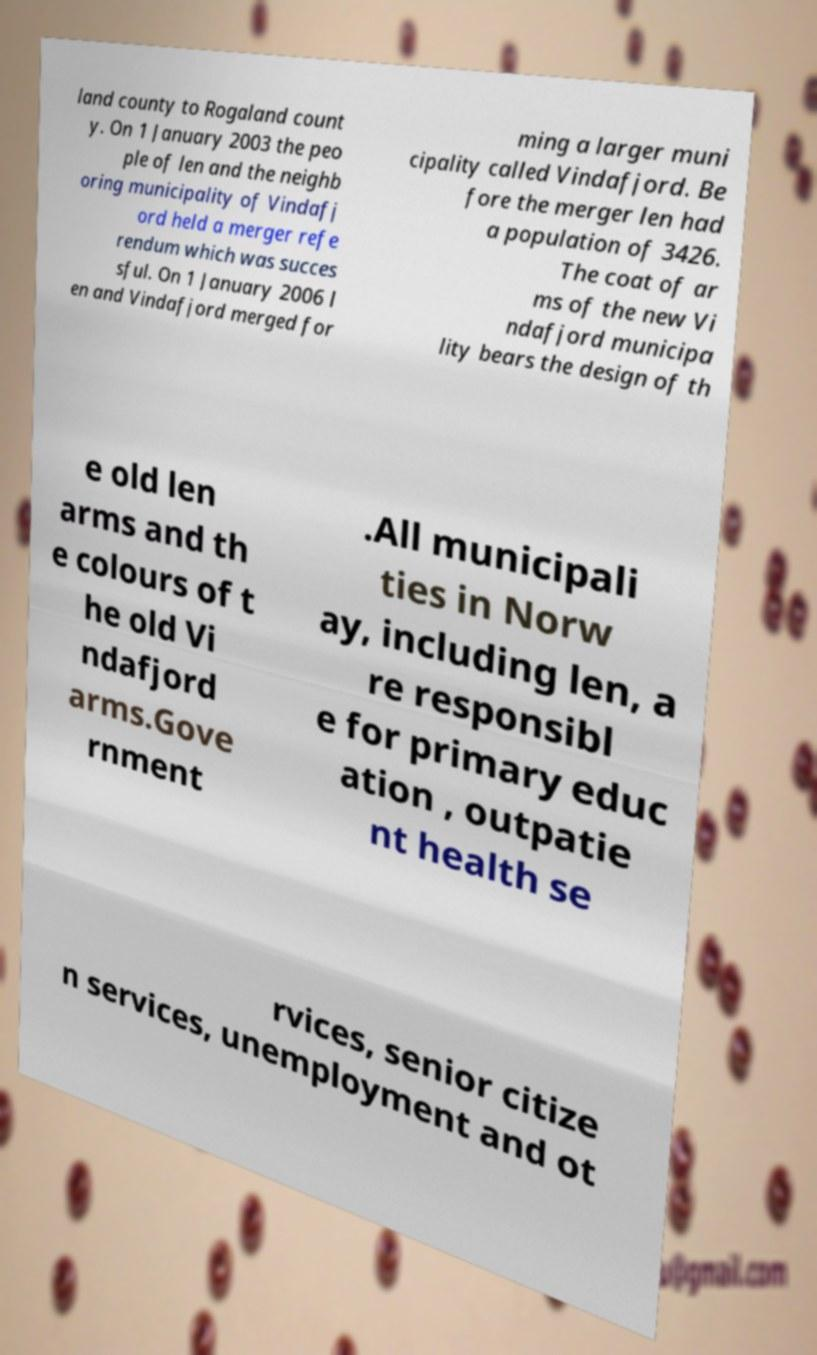What messages or text are displayed in this image? I need them in a readable, typed format. land county to Rogaland count y. On 1 January 2003 the peo ple of len and the neighb oring municipality of Vindafj ord held a merger refe rendum which was succes sful. On 1 January 2006 l en and Vindafjord merged for ming a larger muni cipality called Vindafjord. Be fore the merger len had a population of 3426. The coat of ar ms of the new Vi ndafjord municipa lity bears the design of th e old len arms and th e colours of t he old Vi ndafjord arms.Gove rnment .All municipali ties in Norw ay, including len, a re responsibl e for primary educ ation , outpatie nt health se rvices, senior citize n services, unemployment and ot 